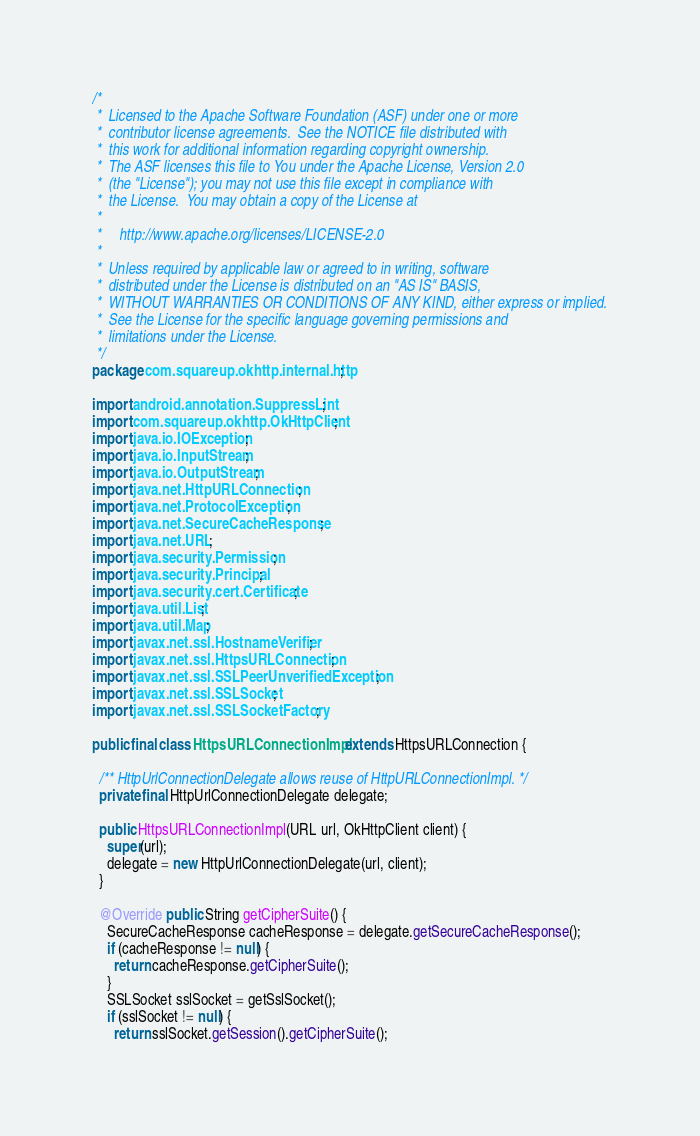Convert code to text. <code><loc_0><loc_0><loc_500><loc_500><_Java_>/*
 *  Licensed to the Apache Software Foundation (ASF) under one or more
 *  contributor license agreements.  See the NOTICE file distributed with
 *  this work for additional information regarding copyright ownership.
 *  The ASF licenses this file to You under the Apache License, Version 2.0
 *  (the "License"); you may not use this file except in compliance with
 *  the License.  You may obtain a copy of the License at
 *
 *     http://www.apache.org/licenses/LICENSE-2.0
 *
 *  Unless required by applicable law or agreed to in writing, software
 *  distributed under the License is distributed on an "AS IS" BASIS,
 *  WITHOUT WARRANTIES OR CONDITIONS OF ANY KIND, either express or implied.
 *  See the License for the specific language governing permissions and
 *  limitations under the License.
 */
package com.squareup.okhttp.internal.http;

import android.annotation.SuppressLint;
import com.squareup.okhttp.OkHttpClient;
import java.io.IOException;
import java.io.InputStream;
import java.io.OutputStream;
import java.net.HttpURLConnection;
import java.net.ProtocolException;
import java.net.SecureCacheResponse;
import java.net.URL;
import java.security.Permission;
import java.security.Principal;
import java.security.cert.Certificate;
import java.util.List;
import java.util.Map;
import javax.net.ssl.HostnameVerifier;
import javax.net.ssl.HttpsURLConnection;
import javax.net.ssl.SSLPeerUnverifiedException;
import javax.net.ssl.SSLSocket;
import javax.net.ssl.SSLSocketFactory;

public final class HttpsURLConnectionImpl extends HttpsURLConnection {

  /** HttpUrlConnectionDelegate allows reuse of HttpURLConnectionImpl. */
  private final HttpUrlConnectionDelegate delegate;

  public HttpsURLConnectionImpl(URL url, OkHttpClient client) {
    super(url);
    delegate = new HttpUrlConnectionDelegate(url, client);
  }

  @Override public String getCipherSuite() {
    SecureCacheResponse cacheResponse = delegate.getSecureCacheResponse();
    if (cacheResponse != null) {
      return cacheResponse.getCipherSuite();
    }
    SSLSocket sslSocket = getSslSocket();
    if (sslSocket != null) {
      return sslSocket.getSession().getCipherSuite();</code> 